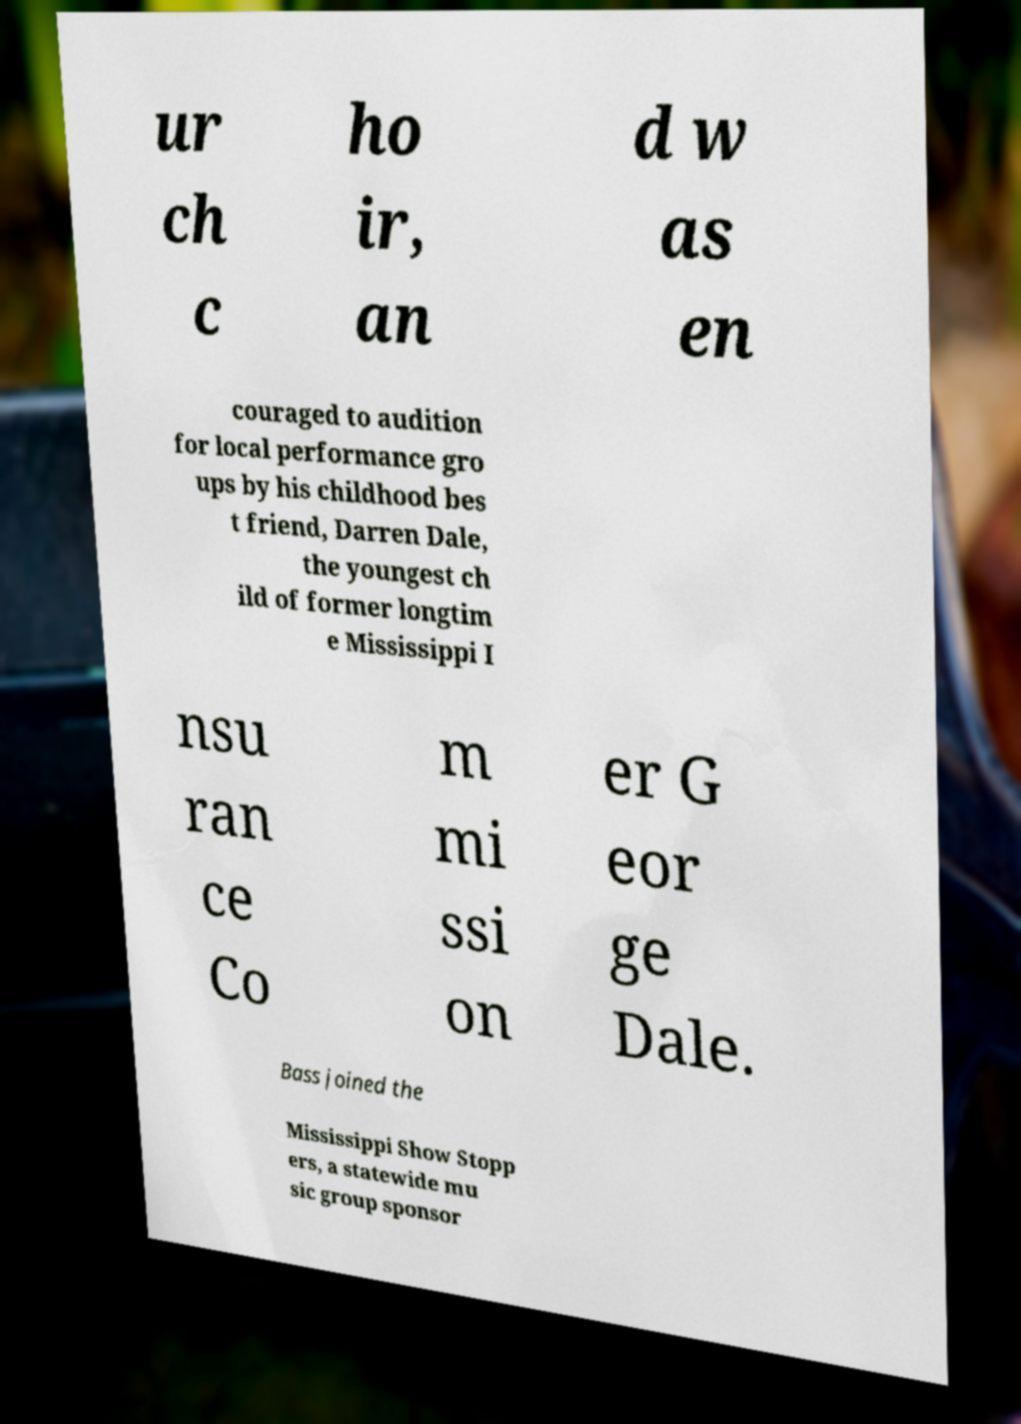What messages or text are displayed in this image? I need them in a readable, typed format. ur ch c ho ir, an d w as en couraged to audition for local performance gro ups by his childhood bes t friend, Darren Dale, the youngest ch ild of former longtim e Mississippi I nsu ran ce Co m mi ssi on er G eor ge Dale. Bass joined the Mississippi Show Stopp ers, a statewide mu sic group sponsor 